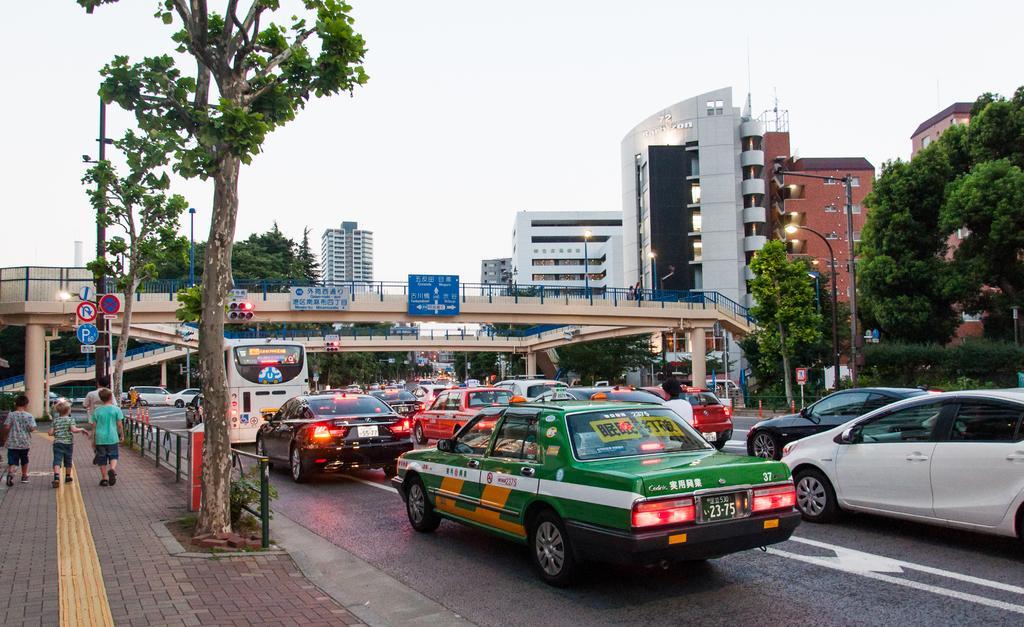Describe this image in one or two sentences. In the image there are many vehicles on the road and on the left side there is a path, few kids are walking on the path and on the right side there is a railing, few trees, caution boards and in the background there is a bridge, in front of the bridge there are traffic signal lights, some boards and behind the bridge there are buildings. 